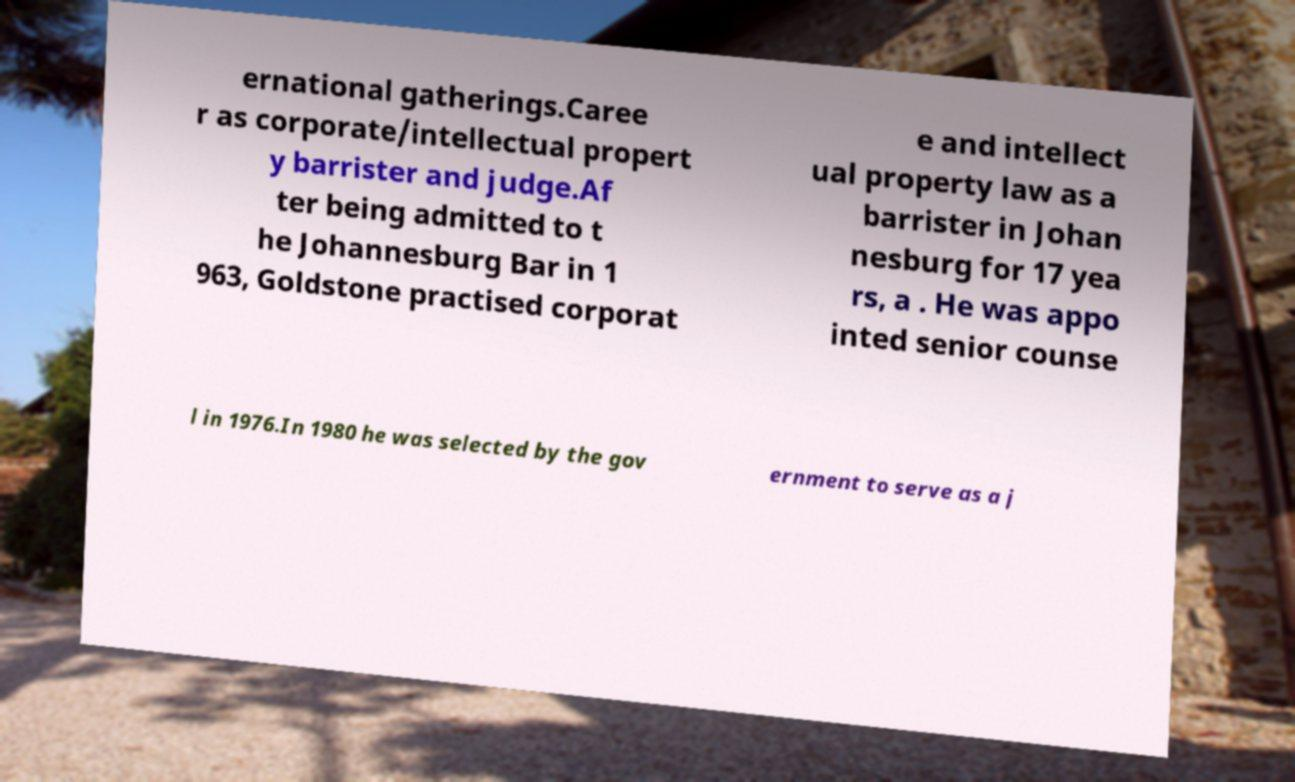What messages or text are displayed in this image? I need them in a readable, typed format. ernational gatherings.Caree r as corporate/intellectual propert y barrister and judge.Af ter being admitted to t he Johannesburg Bar in 1 963, Goldstone practised corporat e and intellect ual property law as a barrister in Johan nesburg for 17 yea rs, a . He was appo inted senior counse l in 1976.In 1980 he was selected by the gov ernment to serve as a j 